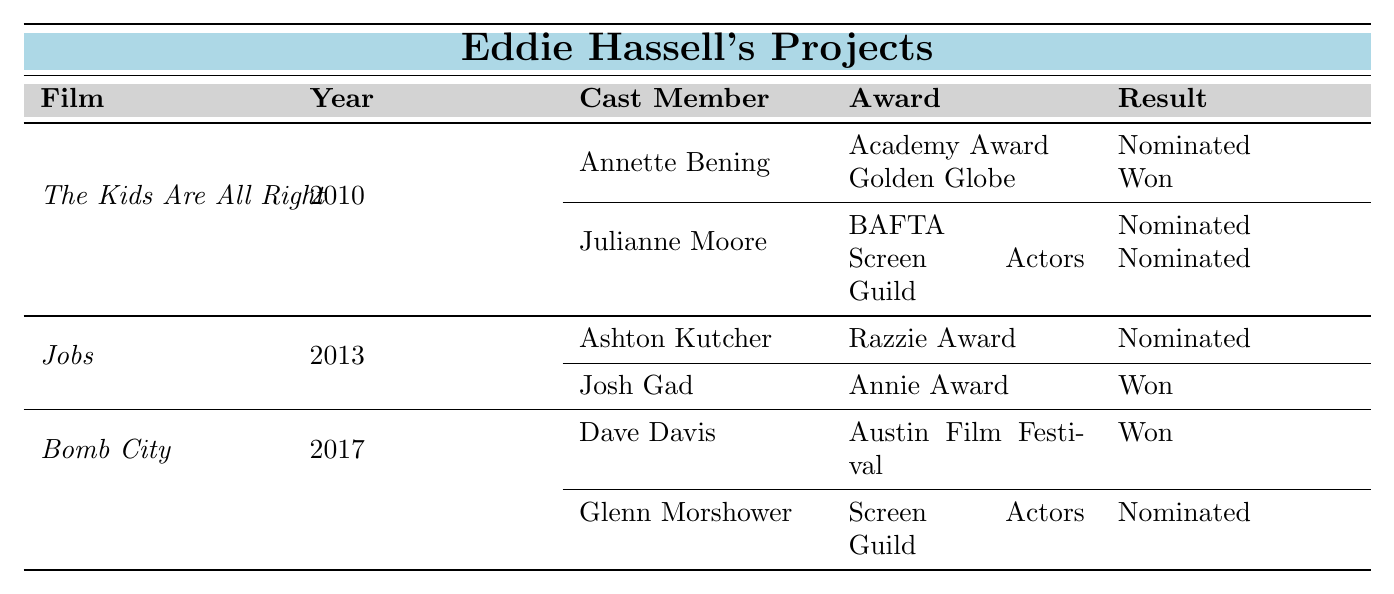What awards was Annette Bening nominated for in "The Kids Are All Right"? According to the table, Annette Bening was nominated for the Academy Award in the Best Actress category.
Answer: Academy Award How many cast members from "Jobs" won an award? The table shows that only Josh Gad won an award (Annie Award), while Ashton Kutcher was nominated for a Razzie Award. Therefore, there is 1 winner.
Answer: 1 Did Glenn Morshower win an award for his role in "Bomb City"? The table indicates that Glenn Morshower was nominated for a Screen Actors Guild award, but it does not show a win for him. Hence, he did not win an award.
Answer: No Which film had the most nominations among cast members? Reviewing the nominations, "The Kids Are All Right" has 4 nominations (2 each for Annette Bening and Julianne Moore), while "Jobs" and "Bomb City" have 1 and 1 nomination, respectively. Thus, "The Kids Are All Right" had the most nominations.
Answer: The Kids Are All Right How many total wins are there for the cast members across all films listed? By summing the wins: Annette Bening (1), Josh Gad (1), and Dave Davis (1) brings the total to 3 wins for cast members across all films.
Answer: 3 Was there a cast member from "Bomb City" who was nominated for multiple awards? The table indicates Glenn Morshower was nominated for 1 award and Dave Davis also received 1 win. Therefore, none of the cast members in "Bomb City" had multiple nominations.
Answer: No Which specific category did Josh Gad win an award for in "Jobs"? According to the table, Josh Gad won an Annie Award for Voice Acting in an Animated Feature Production.
Answer: Voice Acting in an Animated Feature Production Which cast member had the highest number of "Nominated" results? Annette Bening has 1 "Nominated" result, as does Julianne Moore, but since they are from the same film, and the others only have one nomination each. Therefore, both are tied.
Answer: Annette Bening and Julianne Moore 